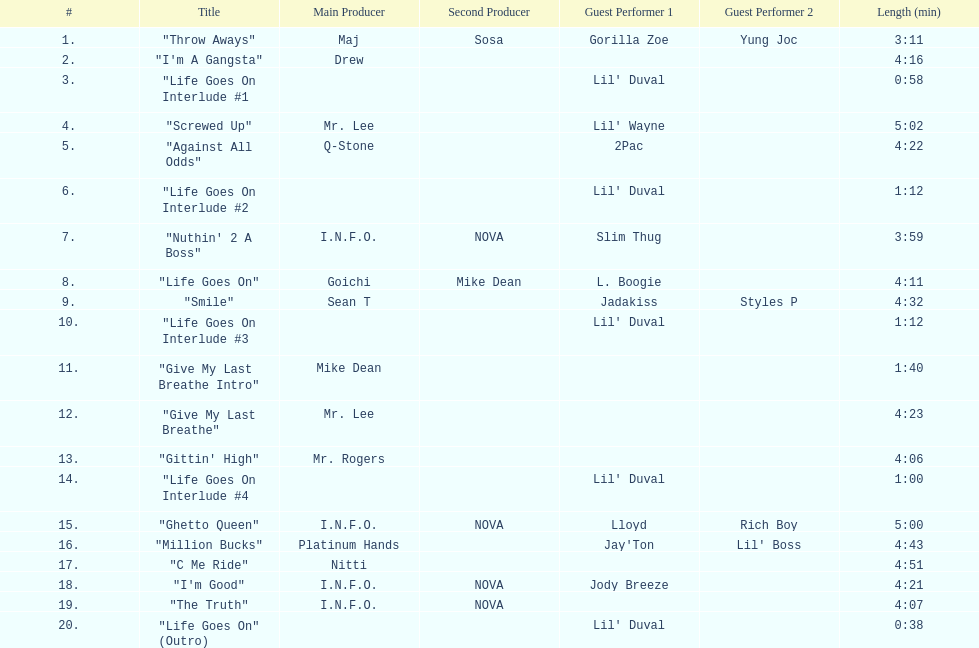Which tracks feature the same producer(s) in consecutive order on this album? "I'm Good", "The Truth". 